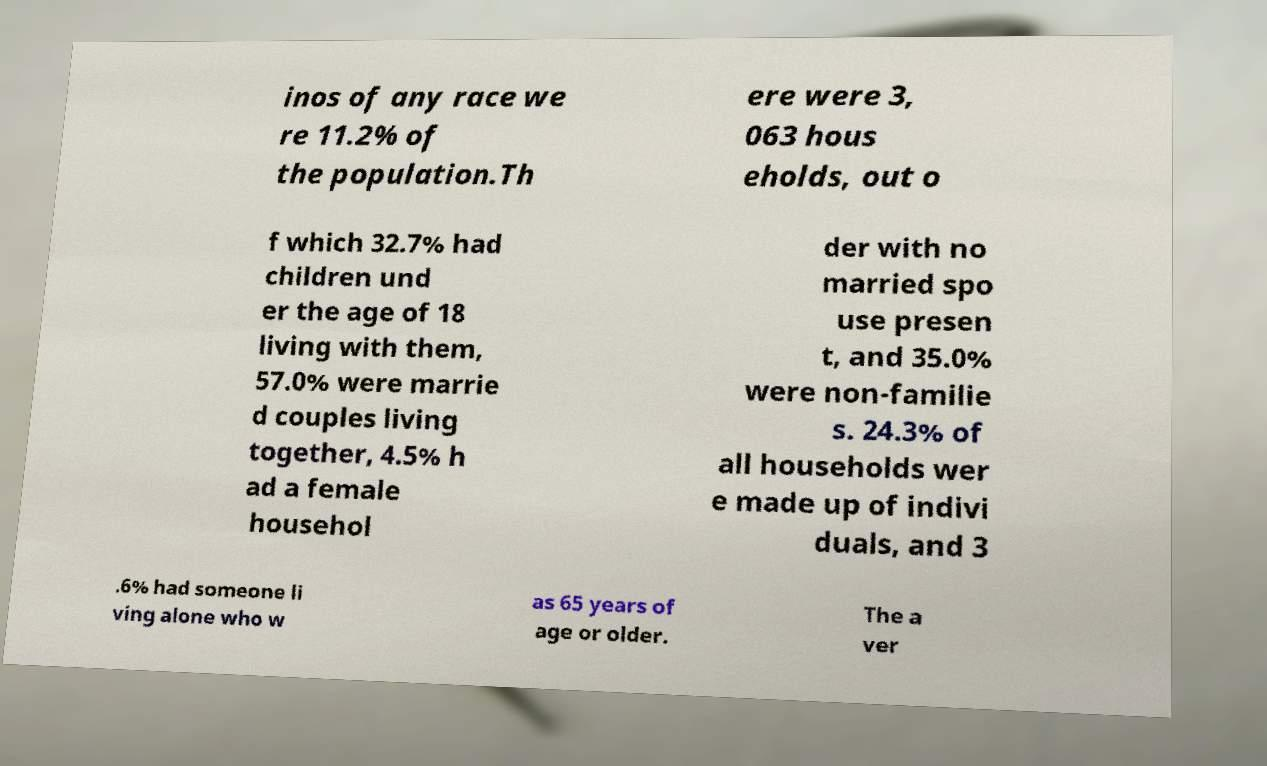There's text embedded in this image that I need extracted. Can you transcribe it verbatim? inos of any race we re 11.2% of the population.Th ere were 3, 063 hous eholds, out o f which 32.7% had children und er the age of 18 living with them, 57.0% were marrie d couples living together, 4.5% h ad a female househol der with no married spo use presen t, and 35.0% were non-familie s. 24.3% of all households wer e made up of indivi duals, and 3 .6% had someone li ving alone who w as 65 years of age or older. The a ver 